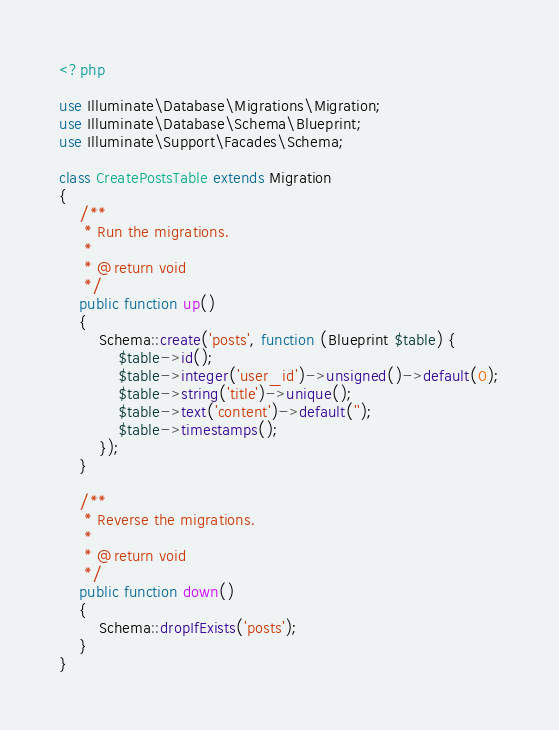Convert code to text. <code><loc_0><loc_0><loc_500><loc_500><_PHP_><?php

use Illuminate\Database\Migrations\Migration;
use Illuminate\Database\Schema\Blueprint;
use Illuminate\Support\Facades\Schema;

class CreatePostsTable extends Migration
{
    /**
     * Run the migrations.
     *
     * @return void
     */
    public function up()
    {
        Schema::create('posts', function (Blueprint $table) {
            $table->id();
            $table->integer('user_id')->unsigned()->default(0);
            $table->string('title')->unique();
            $table->text('content')->default('');
            $table->timestamps();
        });
    }

    /**
     * Reverse the migrations.
     *
     * @return void
     */
    public function down()
    {
        Schema::dropIfExists('posts');
    }
}
</code> 